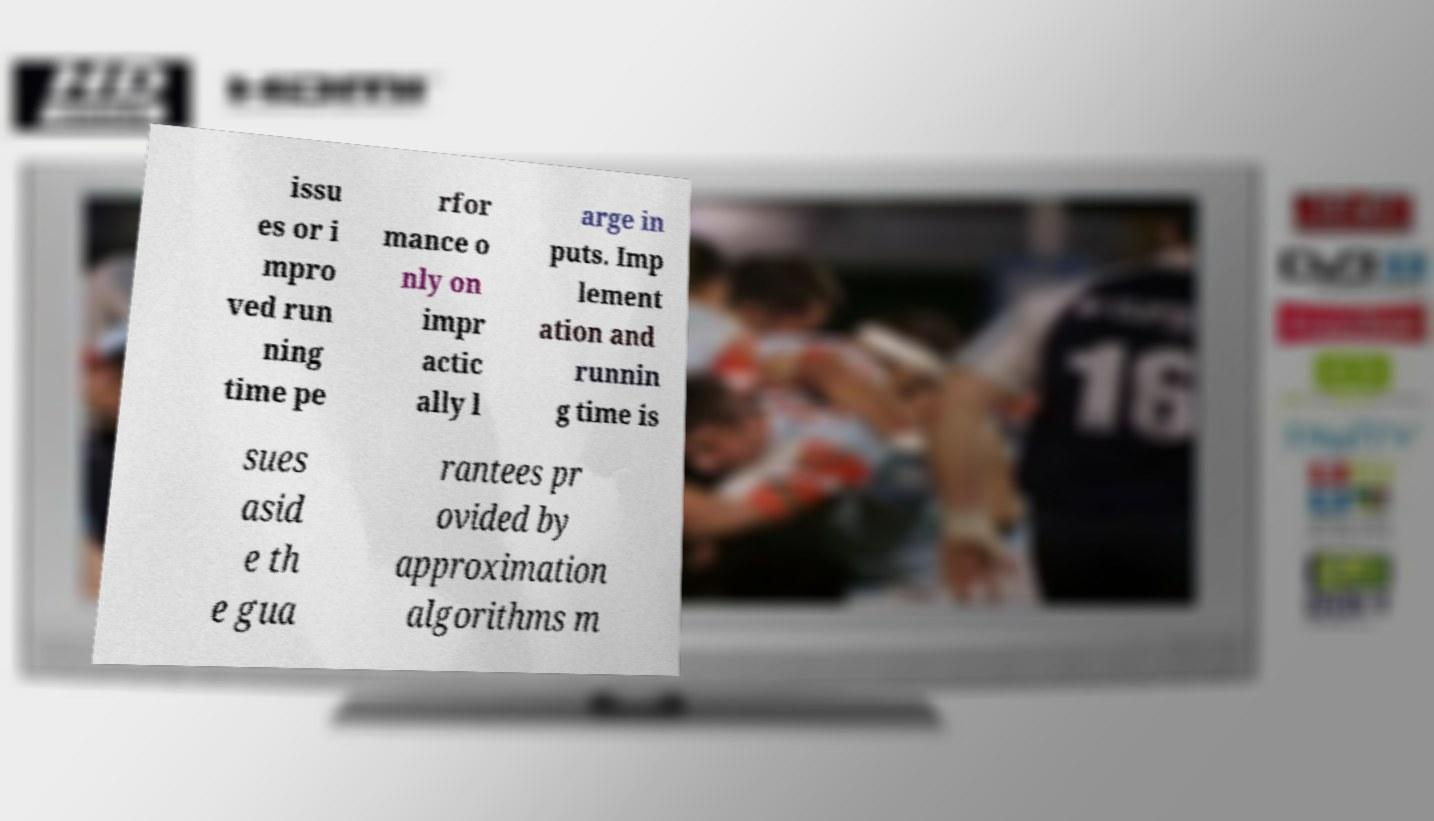Could you extract and type out the text from this image? issu es or i mpro ved run ning time pe rfor mance o nly on impr actic ally l arge in puts. Imp lement ation and runnin g time is sues asid e th e gua rantees pr ovided by approximation algorithms m 